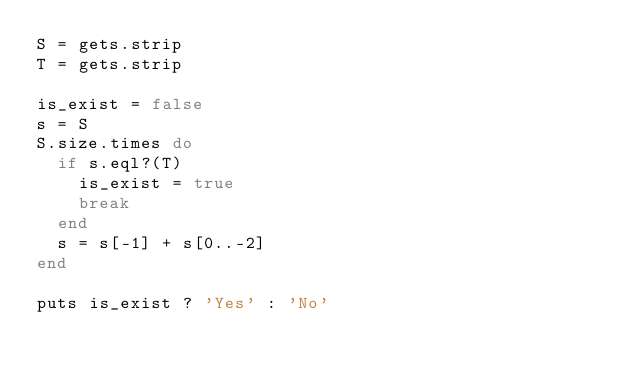<code> <loc_0><loc_0><loc_500><loc_500><_Ruby_>S = gets.strip
T = gets.strip

is_exist = false
s = S
S.size.times do 
  if s.eql?(T)
    is_exist = true
    break
  end
  s = s[-1] + s[0..-2]
end

puts is_exist ? 'Yes' : 'No'
</code> 